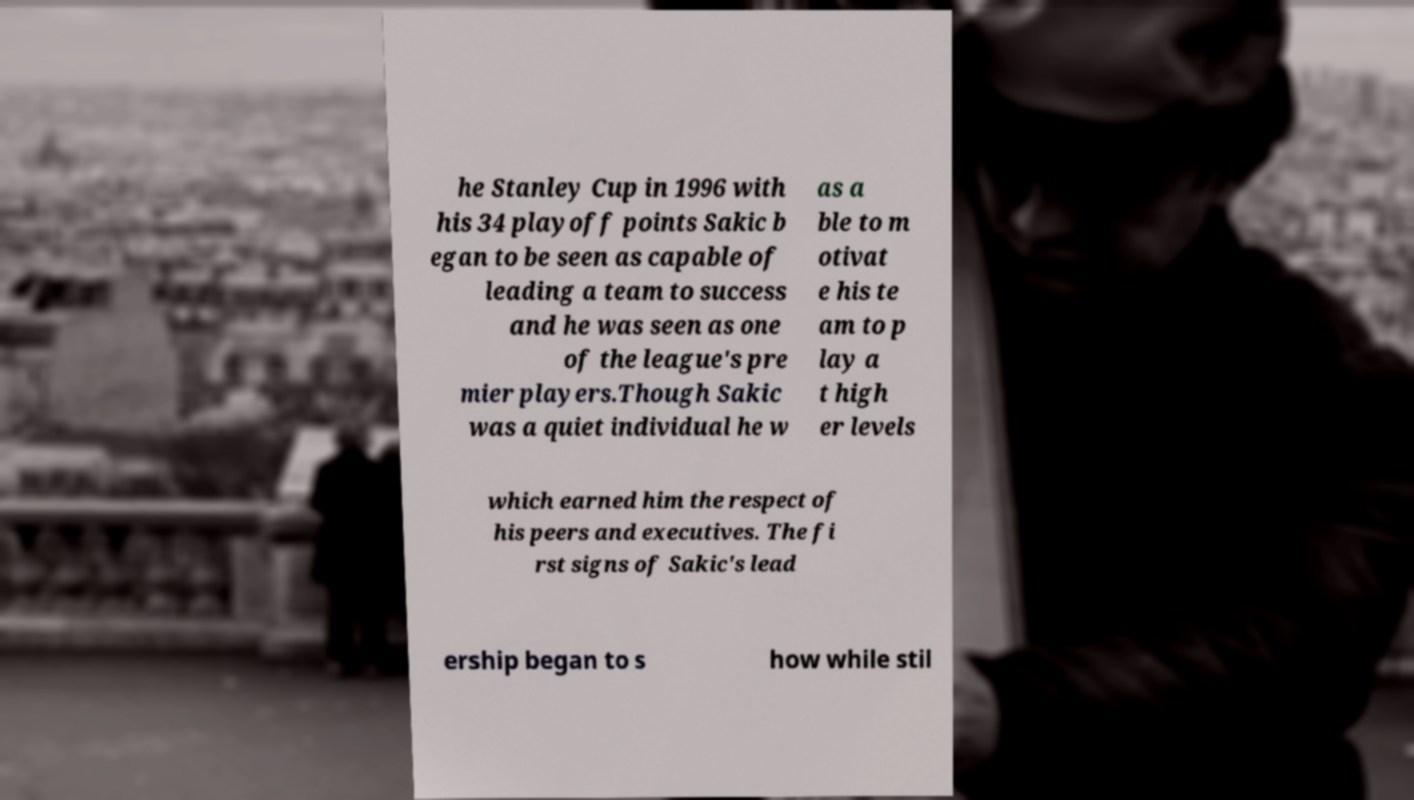Can you accurately transcribe the text from the provided image for me? he Stanley Cup in 1996 with his 34 playoff points Sakic b egan to be seen as capable of leading a team to success and he was seen as one of the league's pre mier players.Though Sakic was a quiet individual he w as a ble to m otivat e his te am to p lay a t high er levels which earned him the respect of his peers and executives. The fi rst signs of Sakic's lead ership began to s how while stil 